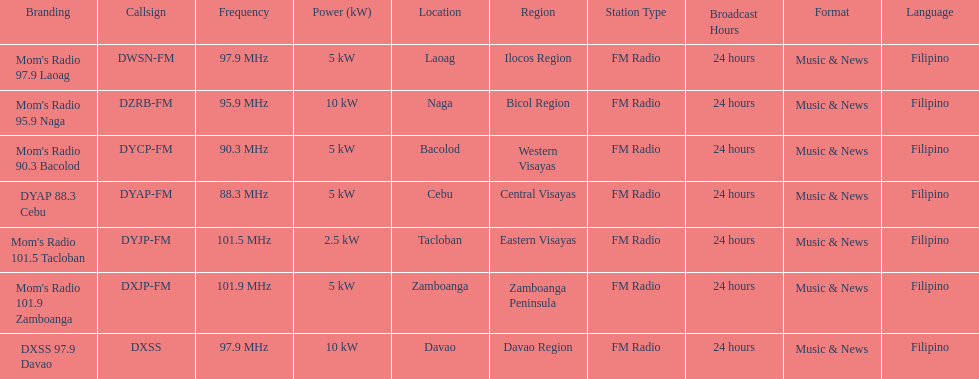What is the only radio station with a frequency below 90 mhz? DYAP 88.3 Cebu. 